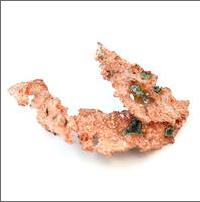why? Native copper is considered a mineral because it possesses all the requisite characteristics: it's a naturally occurring solid; it forms through geological processes rather than biological activity; it's chemically homogeneous, consisting only of copper atoms; and it has a specific crystal structure which remains constant regardless of where it's found. These traits ensure that native copper is not only a pure element but also an excellent example of mineral properties. 